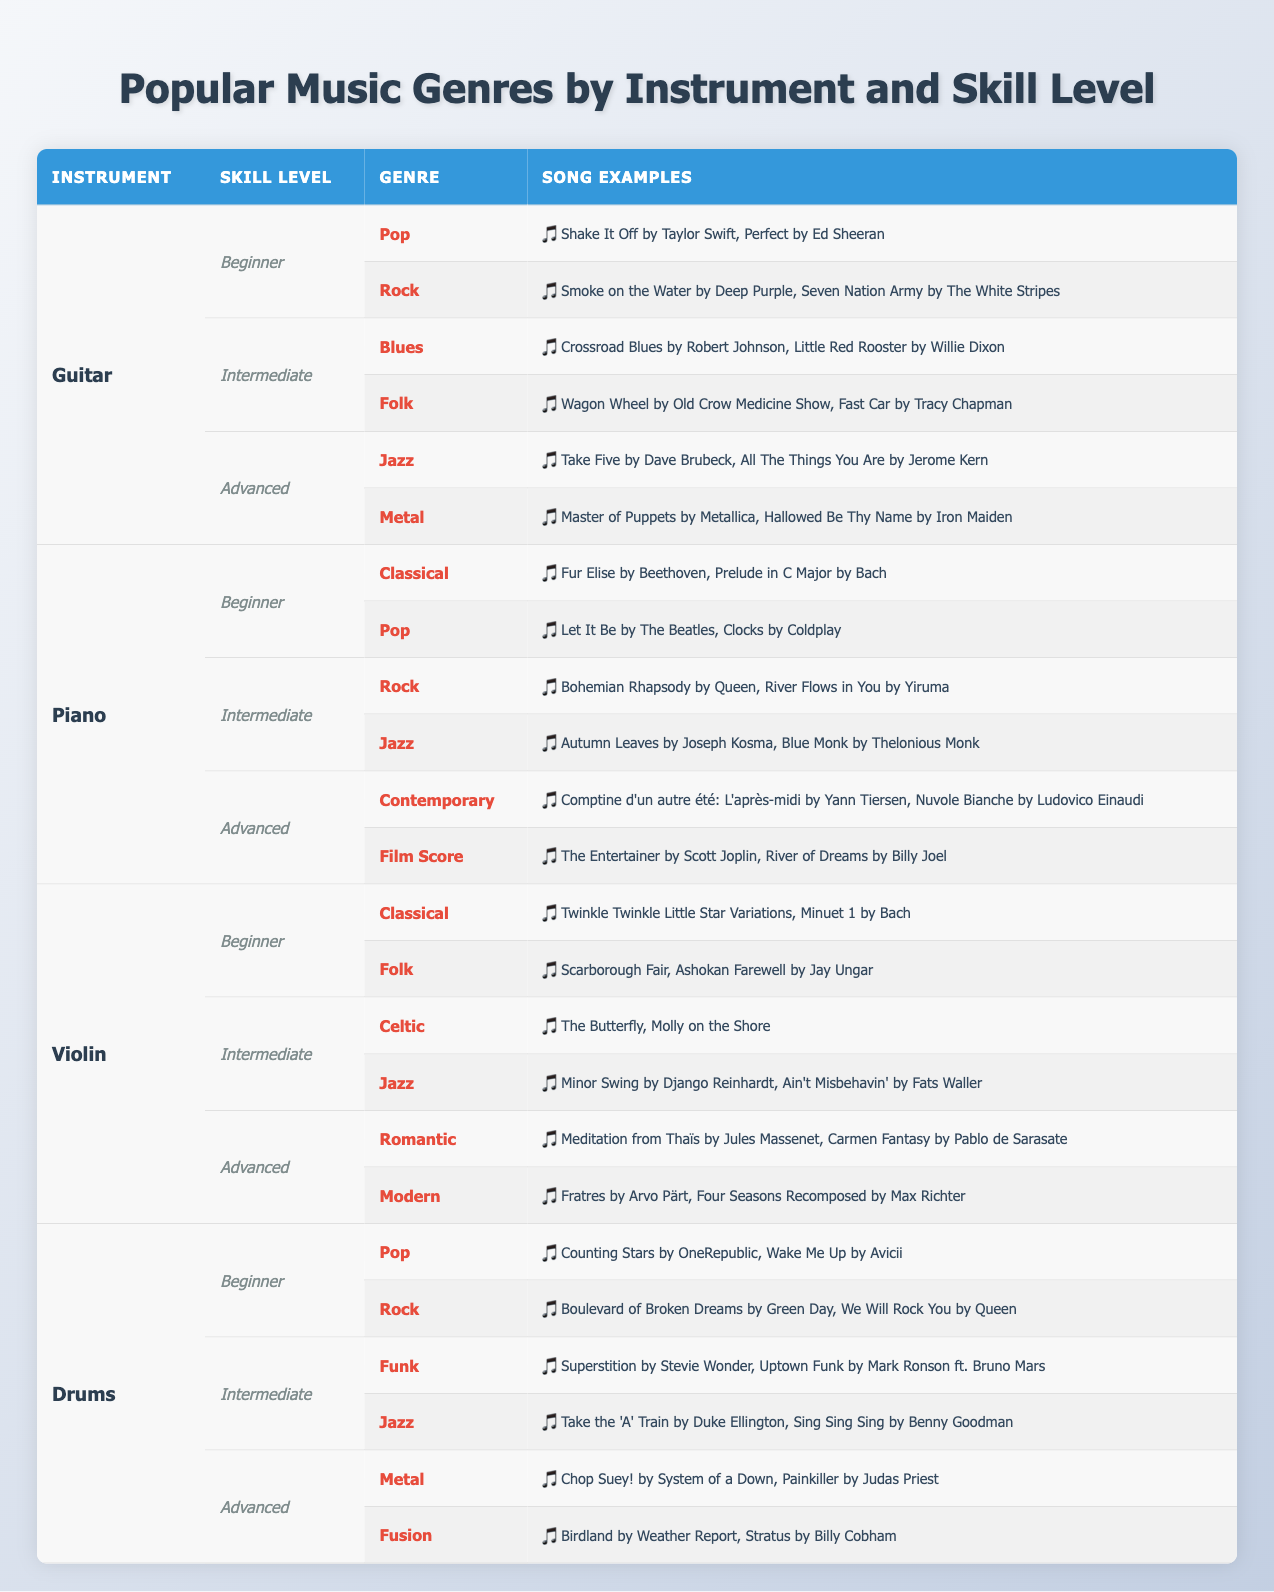What genre is favored by beginner guitar students? According to the table, beginner guitar students favor Pop and Rock genres.
Answer: Pop and Rock Which instrument has the most advanced genres listed? The table shows that all instruments have two advanced genres listed, so there is no single instrument with the most advanced genres.
Answer: None Is "Take Five by Dave Brubeck" a recommended song for advanced guitar players? The song "Take Five" is listed under Jazz for advanced guitar students, so it is a recommended song for them.
Answer: Yes How many song examples are provided for intermediate piano students learning Jazz? For intermediate piano students learning Jazz, there are two song examples listed: "Autumn Leaves" and "Blue Monk." Thus, the answer is 2.
Answer: 2 Which instrument has the genre "Funk" in the intermediate skill level? The table indicates that Drums is the instrument associated with the genre "Funk" in the intermediate skill level.
Answer: Drums Is there a genre classified under beginner for all instruments? Reviewing the table shows that each instrument has different genres under beginner, thus there is no common genre under beginner for all instruments.
Answer: No What is the total number of song examples given for beginner levels across all instruments? The total number of song examples at beginner levels are: Guitar (4), Piano (4), Violin (4), and Drums (4). So, total = 4 + 4 + 4 + 4 = 16.
Answer: 16 Which genres do beginner violin students learn, and how many song examples are there for each? Beginner violin students learn Classical (2 examples) and Folk (2 examples). Thus, total song examples for both genres are 4.
Answer: Classical: 2, Folk: 2 Is there a genre for advanced piano students that includes film music? Yes, the table lists "Film Score" as one of the advanced genres for piano students.
Answer: Yes Which genre has the least amount of song examples for intermediate guitar students? The Blues and Folk genres for intermediate guitar students each have 2 song examples, and both are the least in this category.
Answer: Blues and Folk 